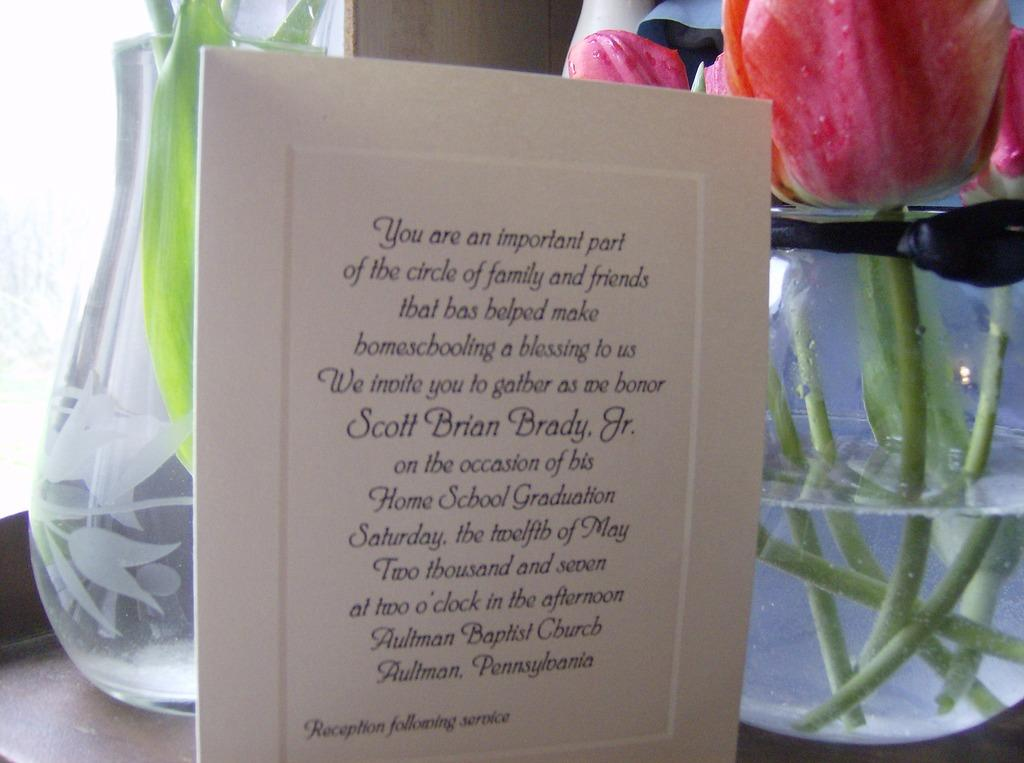What is the main subject in the center of the image? There is a greeting in the center of the image. What can be seen in the background of the image? There are flowers in water and a window in the background of the image. What else is present in the background of the image? There is also a wall in the background of the image. What type of record can be seen on the wall in the image? There is no record present on the wall in the image. How many geese are visible in the image? There are no geese visible in the image. 